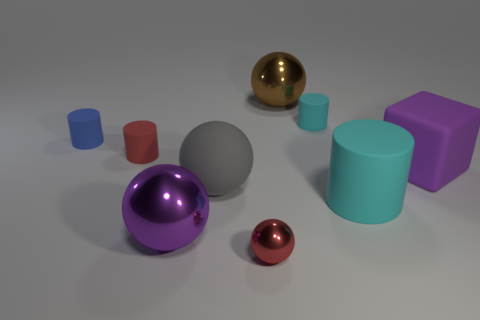What shapes and colors are present in the image? The image showcases an assortment of shapes including spheres, cylinders, and rectangular solids. The colors featured range from vibrant purples and blues to subtle shades of gray and gold. 